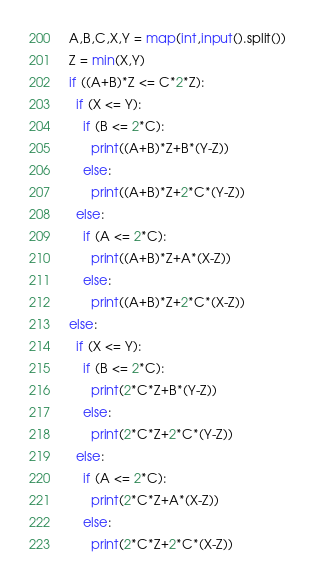<code> <loc_0><loc_0><loc_500><loc_500><_Python_>A,B,C,X,Y = map(int,input().split())
Z = min(X,Y)
if ((A+B)*Z <= C*2*Z):
  if (X <= Y):
    if (B <= 2*C):
      print((A+B)*Z+B*(Y-Z))
    else:
      print((A+B)*Z+2*C*(Y-Z))
  else:
    if (A <= 2*C):
      print((A+B)*Z+A*(X-Z))
    else:
      print((A+B)*Z+2*C*(X-Z))
else:
  if (X <= Y):
    if (B <= 2*C):
      print(2*C*Z+B*(Y-Z))
    else:
      print(2*C*Z+2*C*(Y-Z))
  else:
    if (A <= 2*C):
      print(2*C*Z+A*(X-Z))
    else:
      print(2*C*Z+2*C*(X-Z))</code> 